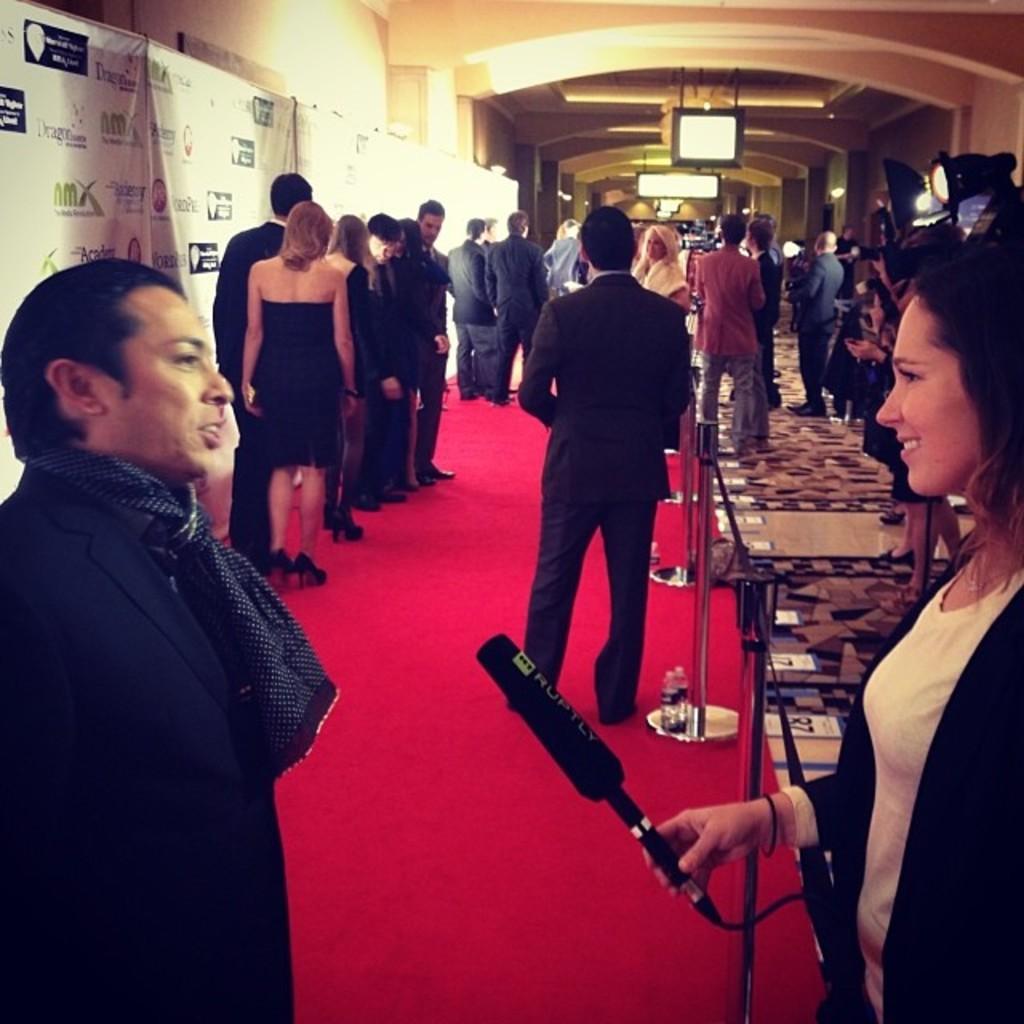In one or two sentences, can you explain what this image depicts? In the image we can see two persons were standing and they were smiling and she is holding microphone. In the background there is a banner,wall,light,monitor,red carpet and group of persons were standing. 